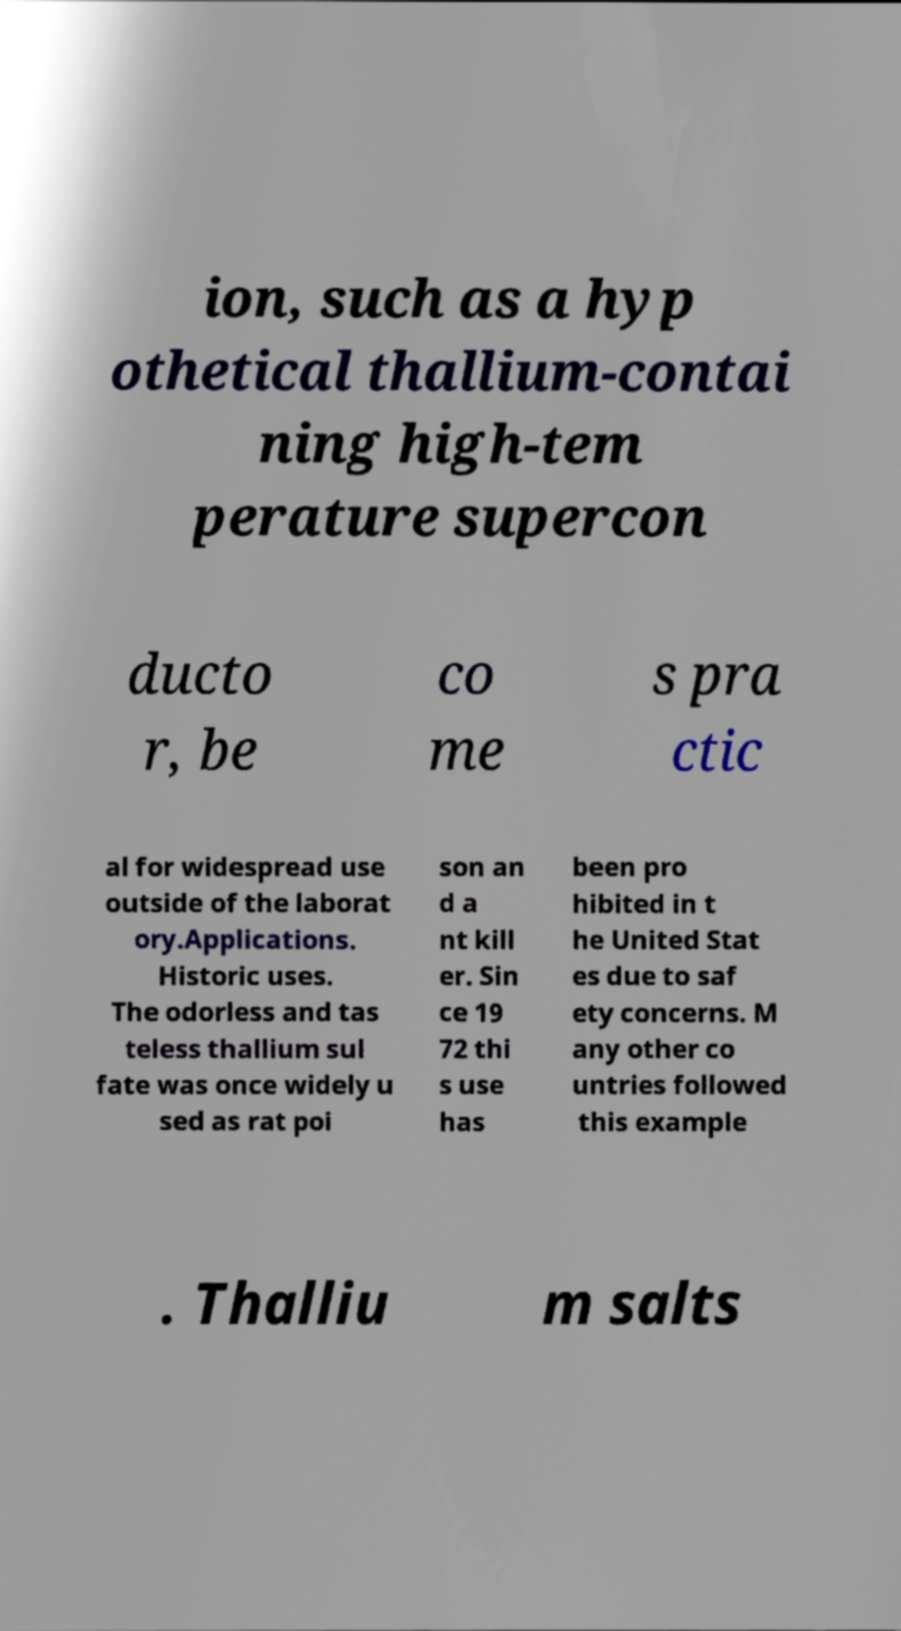Can you read and provide the text displayed in the image?This photo seems to have some interesting text. Can you extract and type it out for me? ion, such as a hyp othetical thallium-contai ning high-tem perature supercon ducto r, be co me s pra ctic al for widespread use outside of the laborat ory.Applications. Historic uses. The odorless and tas teless thallium sul fate was once widely u sed as rat poi son an d a nt kill er. Sin ce 19 72 thi s use has been pro hibited in t he United Stat es due to saf ety concerns. M any other co untries followed this example . Thalliu m salts 